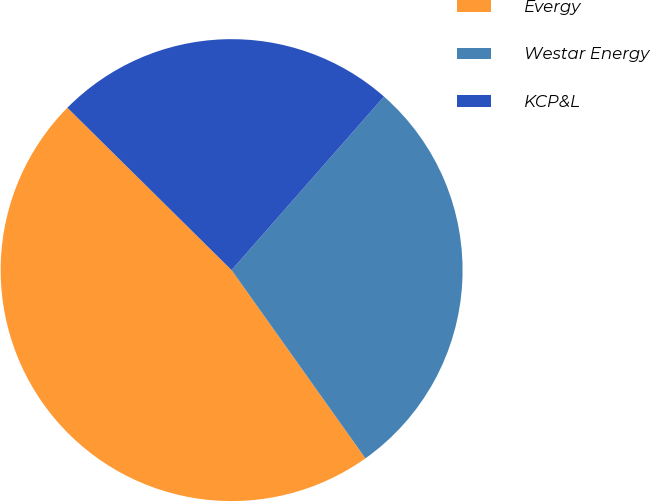<chart> <loc_0><loc_0><loc_500><loc_500><pie_chart><fcel>Evergy<fcel>Westar Energy<fcel>KCP&L<nl><fcel>47.25%<fcel>28.7%<fcel>24.06%<nl></chart> 